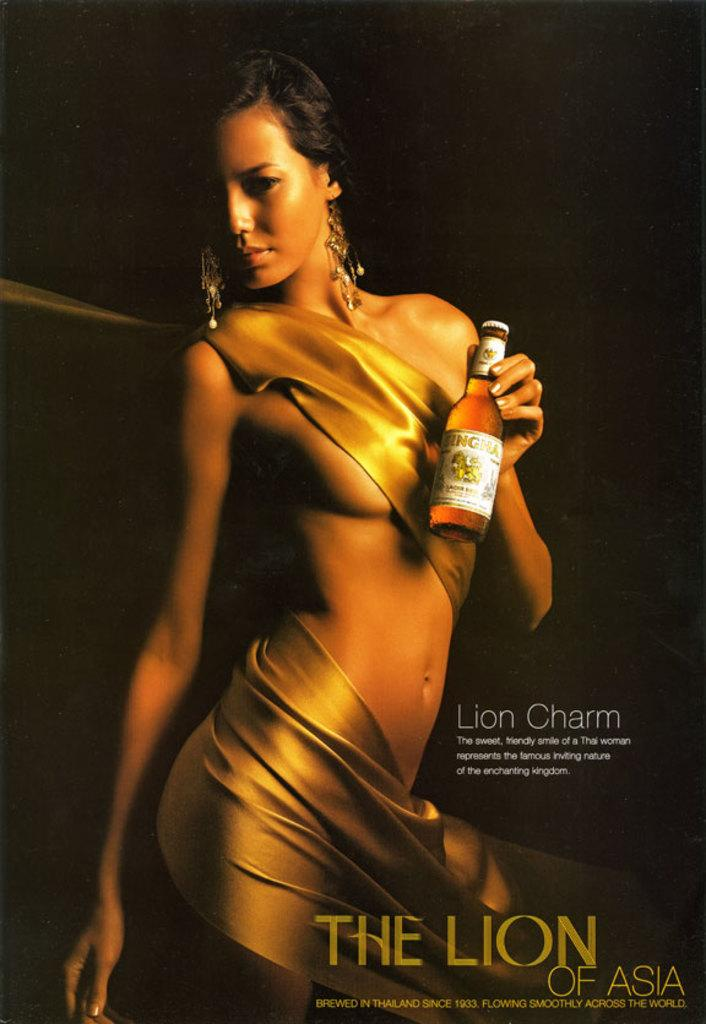Who is the main subject in the image? There is a woman in the image. What is the woman wearing? The woman is wearing a golden outfit. What is the woman doing in the image? The woman is standing. What is the woman holding in her hand? The woman is holding a beer bottle in her hand. What type of pet is the woman holding in the image? There is no pet visible in the image; the woman is holding a beer bottle. 